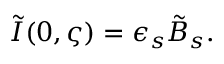<formula> <loc_0><loc_0><loc_500><loc_500>\tilde { I } ( 0 , \varsigma ) = \epsilon _ { s } \tilde { B } _ { s } .</formula> 